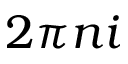<formula> <loc_0><loc_0><loc_500><loc_500>2 \pi n i</formula> 